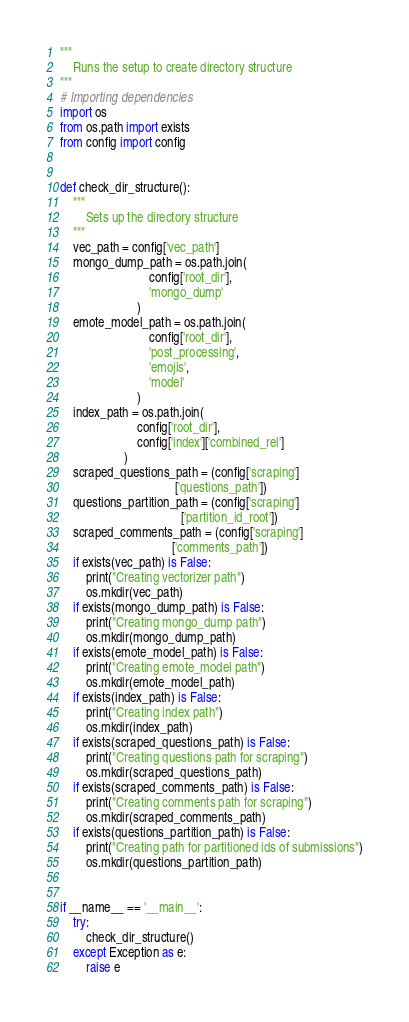<code> <loc_0><loc_0><loc_500><loc_500><_Python_>"""
    Runs the setup to create directory structure
"""
# Importing dependencies
import os
from os.path import exists
from config import config


def check_dir_structure():
    """
        Sets up the directory structure
    """
    vec_path = config['vec_path']
    mongo_dump_path = os.path.join(
                            config['root_dir'],
                            'mongo_dump'
                        )
    emote_model_path = os.path.join(
                            config['root_dir'],
                            'post_processing',
                            'emojis',
                            'model'
                        )
    index_path = os.path.join(
                        config['root_dir'],
                        config['index']['combined_rel']
                    )
    scraped_questions_path = (config['scraping']
                                    ['questions_path'])
    questions_partition_path = (config['scraping']
                                      ['partition_id_root'])
    scraped_comments_path = (config['scraping']
                                   ['comments_path'])
    if exists(vec_path) is False:
        print("Creating vectorizer path")
        os.mkdir(vec_path)
    if exists(mongo_dump_path) is False:
        print("Creating mongo_dump path")
        os.mkdir(mongo_dump_path)
    if exists(emote_model_path) is False:
        print("Creating emote_model path")
        os.mkdir(emote_model_path)
    if exists(index_path) is False:
        print("Creating index path")
        os.mkdir(index_path)
    if exists(scraped_questions_path) is False:
        print("Creating questions path for scraping")
        os.mkdir(scraped_questions_path)
    if exists(scraped_comments_path) is False:
        print("Creating comments path for scraping")
        os.mkdir(scraped_comments_path)
    if exists(questions_partition_path) is False:
        print("Creating path for partitioned ids of submissions")
        os.mkdir(questions_partition_path)


if __name__ == '__main__':
    try:
        check_dir_structure()
    except Exception as e:
        raise e
</code> 